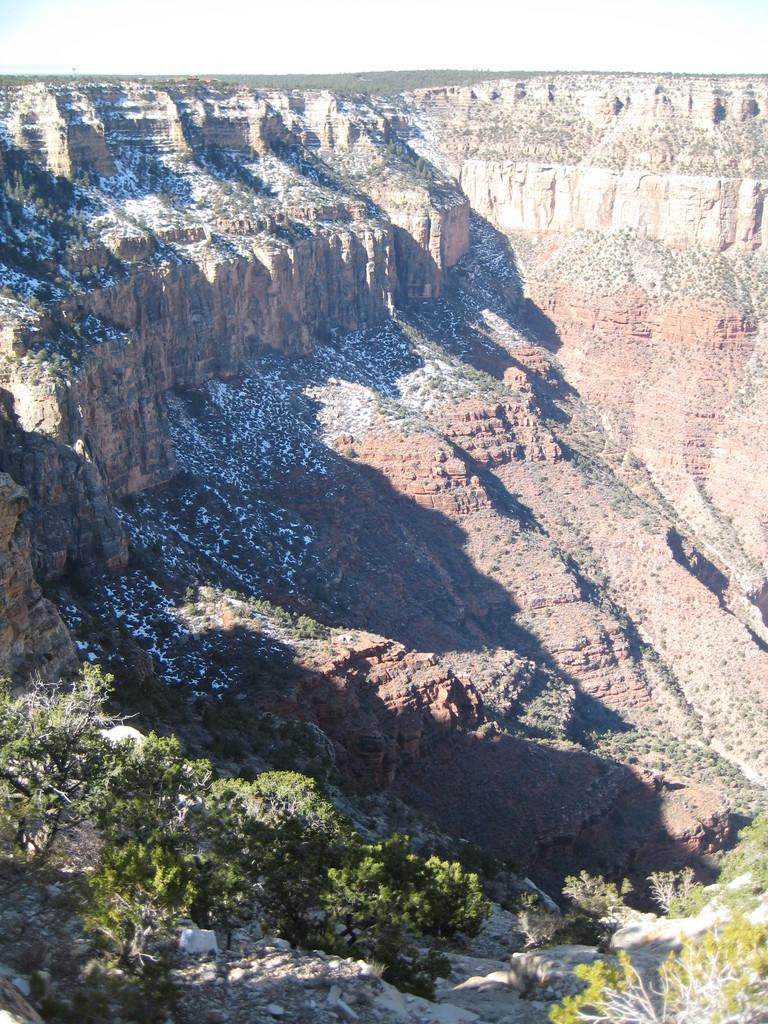What is the main geographical feature in the image? There is a mountain in the image. What type of vegetation can be seen at the base of the mountain? Plants and trees are present at the bottom of the mountain. What is visible at the top of the image? The sky is visible at the top of the image. What can be observed in the sky? Clouds are present in the sky. Is there any quicksand visible on the mountain in the image? There is no quicksand present in the image; it features a mountain with plants and trees at the bottom and clouds in the sky. What is the purpose of the jar in the image? There is no jar present in the image. 